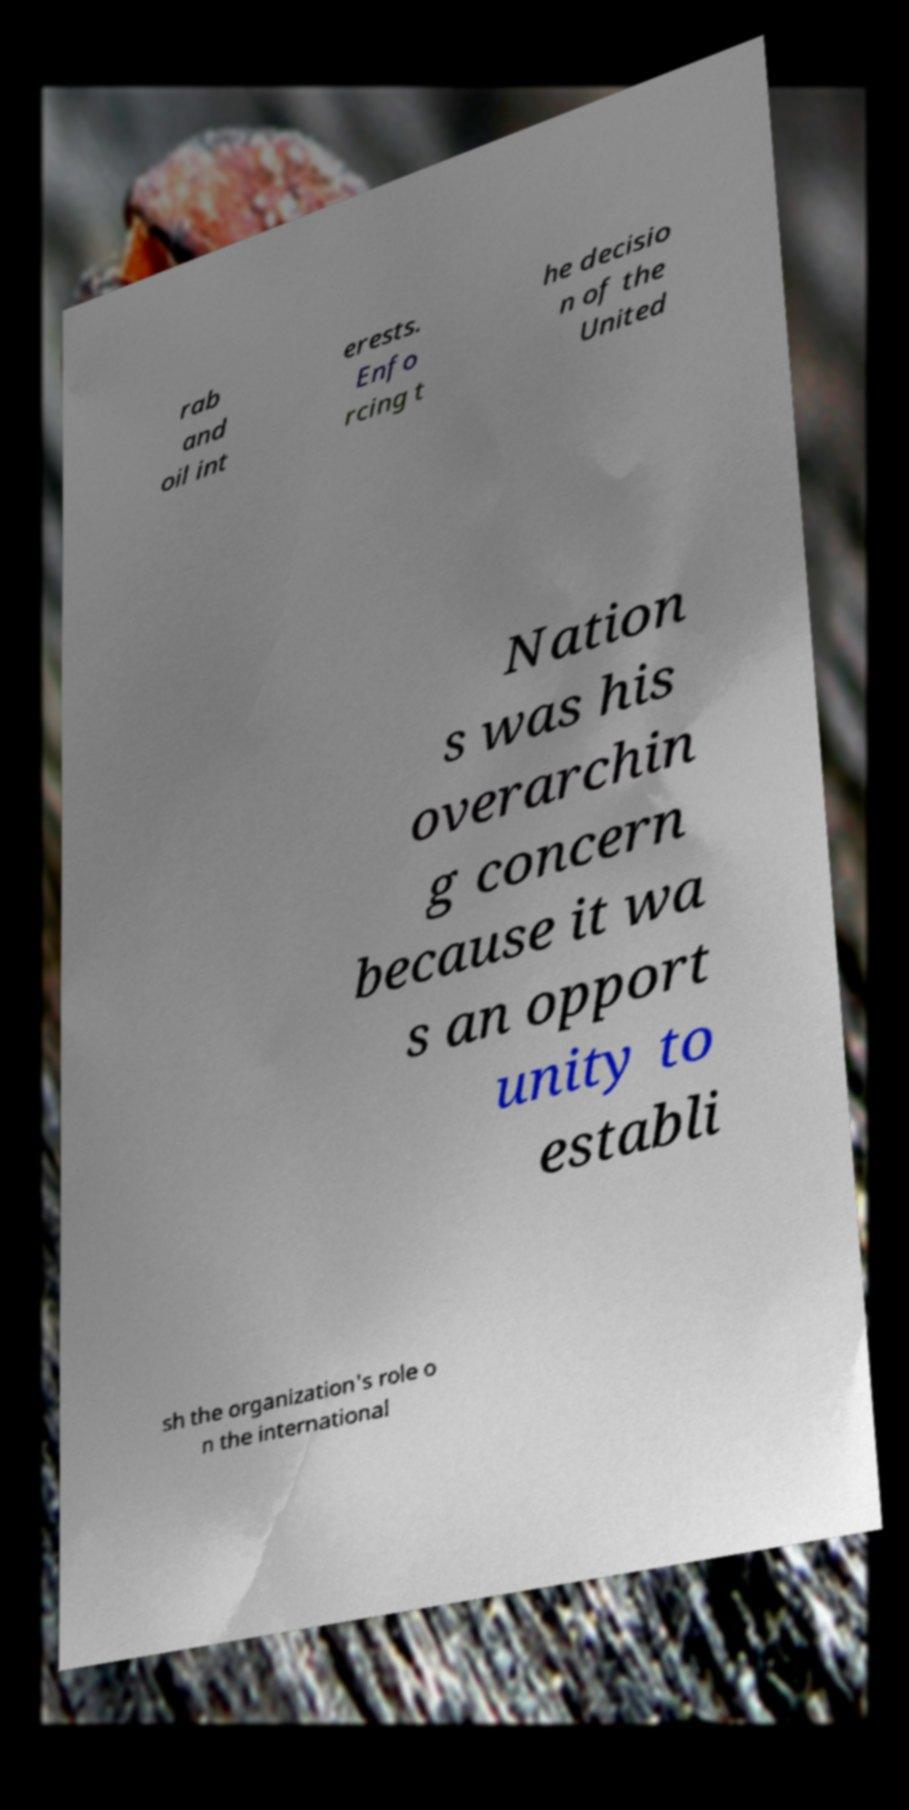Could you assist in decoding the text presented in this image and type it out clearly? rab and oil int erests. Enfo rcing t he decisio n of the United Nation s was his overarchin g concern because it wa s an opport unity to establi sh the organization's role o n the international 